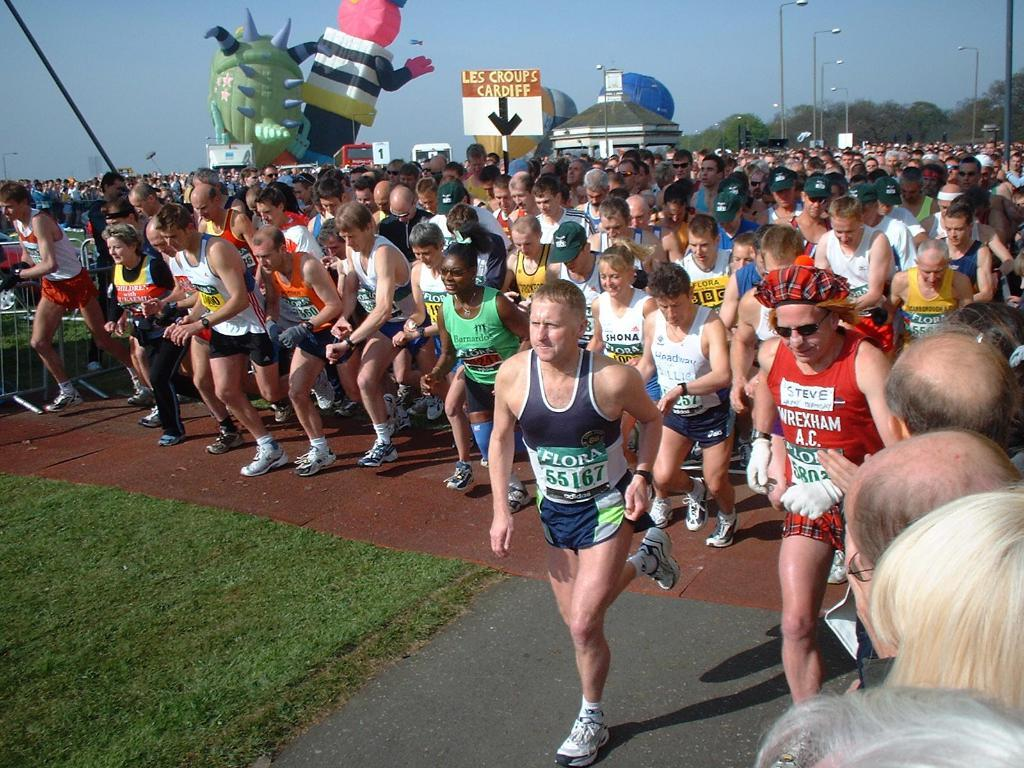What are the people in the image doing? The people in the image are running. What can be seen in the sky in the image? There are air balloons visible in the image. What type of surface is the people running on? The ground is covered with grass. Are there any other objects or structures visible on the road? The provided facts do not mention any other objects or structures on the road. What type of beast is pulling the plough in the image? There is no plough or beast present in the image. 